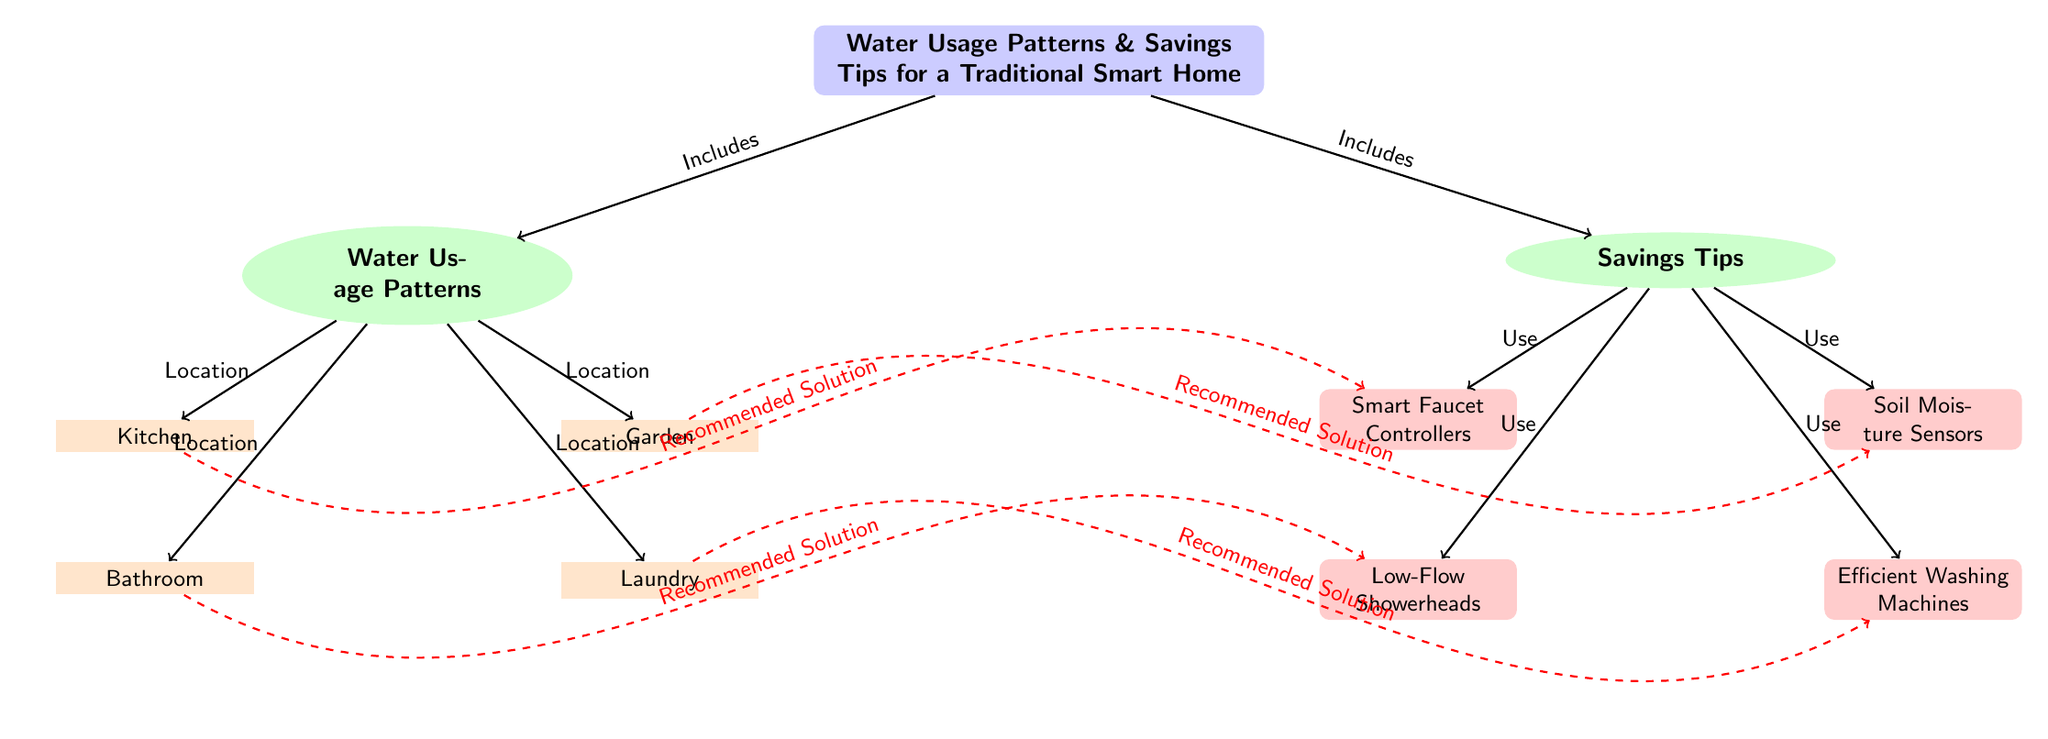What are the two main sections of the diagram? The diagram is divided into two main sections: "Water Usage Patterns" and "Savings Tips." These sections are represented as nodes branching from the main topic node, indicating the primary focus areas of the diagram.
Answer: Water Usage Patterns, Savings Tips How many locations are identified in the water usage patterns? There are four specific locations identified in the "Water Usage Patterns" section: Kitchen, Bathroom, Garden, and Laundry. These are represented as distinct nodes under the main "Water Usage Patterns" node.
Answer: Four Which savings tip is associated with the kitchen? The savings tip associated with the kitchen is "Smart Faucet Controllers." It is connected to the kitchen node with an arrow indicating a recommended solution for that location.
Answer: Smart Faucet Controllers What type of node represents the main theme of the diagram? The main theme of the diagram is represented by a "rectangle" node, which is visually distinct with rounded corners and a blue background, summarizing the overall topic being discussed.
Answer: Rectangle Which savings tip is related to the laundry location? The savings tip related to the laundry location is "Efficient Washing Machines." This information is deduced by following the connection from the laundry node to the tips section.
Answer: Efficient Washing Machines Explain the relationship between the bathroom and the low-flow showerheads. The relationship is defined by a dashed red line labeled "Recommended Solution," indicating that low-flow showerheads are suggested as a water-saving measure specifically for the bathroom usage context. This shows a targeted approach to reduce water consumption in that area.
Answer: Recommended Solution What color represents the savings tips section in the diagram? The savings tips section is colored in orange, which is used to visually distinguish it from other sections of the diagram, notably the water usage patterns section which is colored green.
Answer: Orange Which type of technology is suggested for the garden to conserve water? The suggested technology for the garden is "Soil Moisture Sensors," indicated by an arrow that connects the garden node to the corresponding savings tip node in the tips section.
Answer: Soil Moisture Sensors How is the information structured in the diagram? The information is structured hierarchically with a main topic at the top, branched into two major sections (water usage patterns and savings tips), further divided into specific locations and corresponding technologies or solutions, illustrating a clear flow of information.
Answer: Hierarchically 